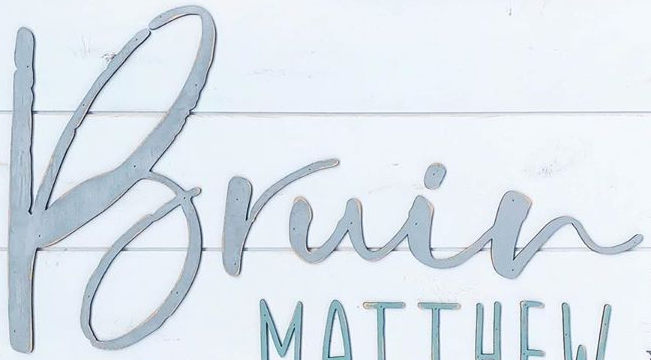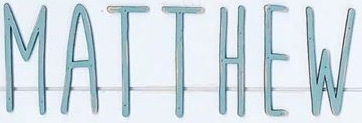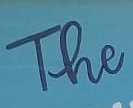What text is displayed in these images sequentially, separated by a semicolon? Bruin; MATTHEW; The 